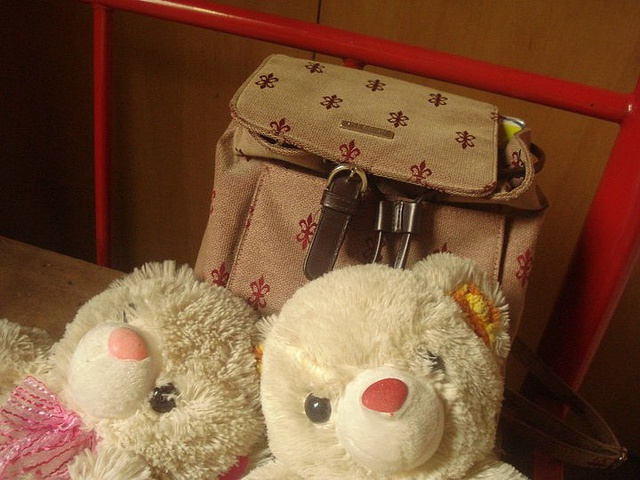Describe the objects in this image and their specific colors. I can see handbag in black, gray, maroon, and olive tones, teddy bear in black, tan, and olive tones, and teddy bear in black, tan, and gray tones in this image. 